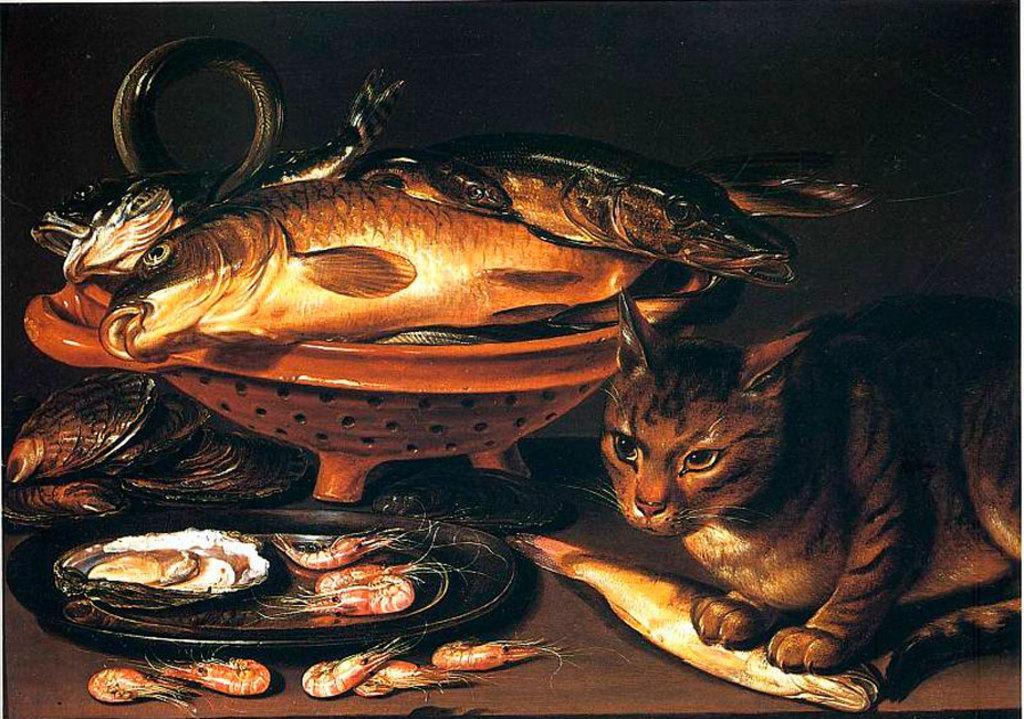Describe this image in one or two sentences. In this picture we can see a cat standing on a fish on to the right side. There are food items in a plate and some other food items on the ground. We can see some fishes in a bowl. Background is black. 